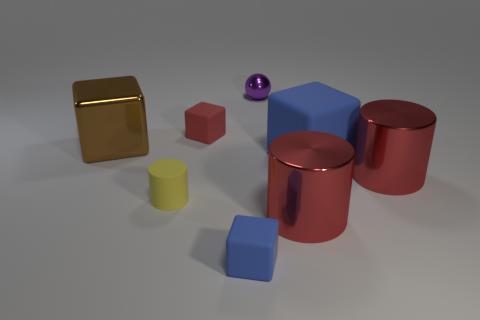The metallic block is what size?
Keep it short and to the point. Large. Are there the same number of big red objects in front of the yellow matte cylinder and yellow matte cylinders?
Offer a terse response. Yes. How many other objects are the same color as the tiny matte cylinder?
Provide a short and direct response. 0. The object that is both to the right of the sphere and in front of the small yellow thing is what color?
Offer a very short reply. Red. How big is the cylinder on the left side of the tiny cube on the left side of the matte block in front of the rubber cylinder?
Ensure brevity in your answer.  Small. How many objects are metallic things that are on the left side of the small red rubber thing or large metal objects that are left of the red rubber block?
Offer a very short reply. 1. What is the shape of the large brown metal thing?
Provide a short and direct response. Cube. What number of other objects are the same material as the large blue cube?
Your response must be concise. 3. What size is the red object that is the same shape as the big brown metal thing?
Your answer should be compact. Small. There is a blue thing in front of the red shiny cylinder that is on the right side of the large block that is right of the matte cylinder; what is its material?
Offer a terse response. Rubber. 